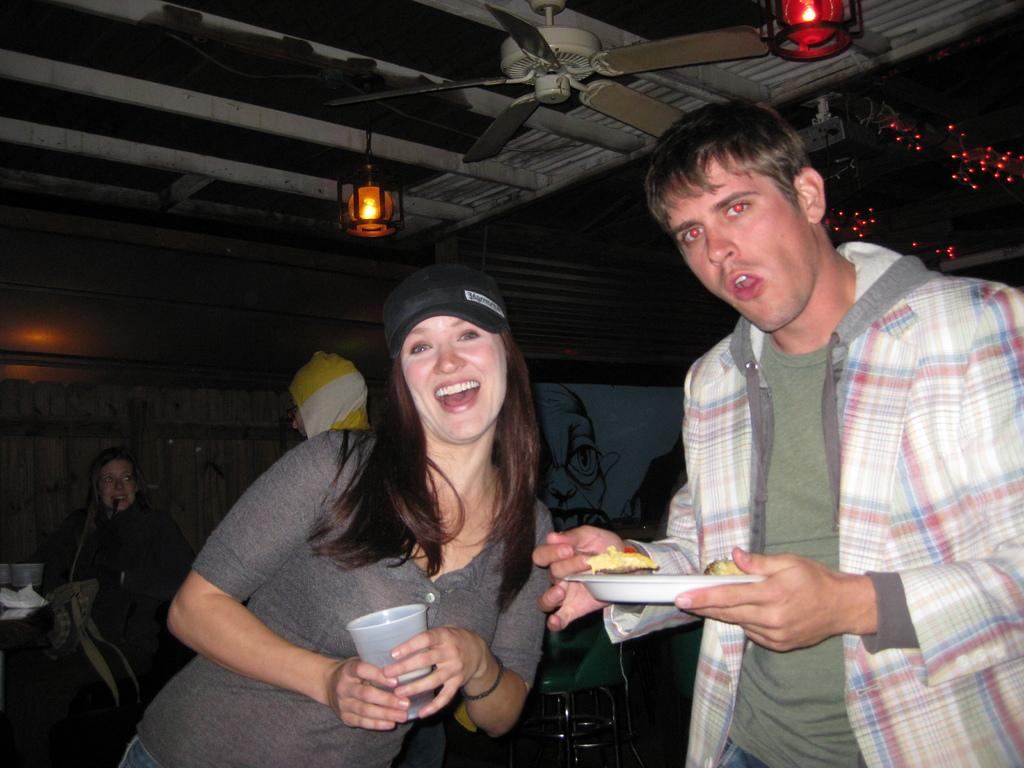How many people are in the foreground of the image? Two persons are standing in the middle of the image. What are the two persons holding in their hands? They are holding a plate and a glass. Can you describe the background of the image? There are other people standing behind them. What is visible on the ceiling in the image? Fans and lights are present on the ceiling. How many bridges can be seen in the image? There are no bridges present in the image. What type of desk is visible in the image? There is no desk present in the image. 